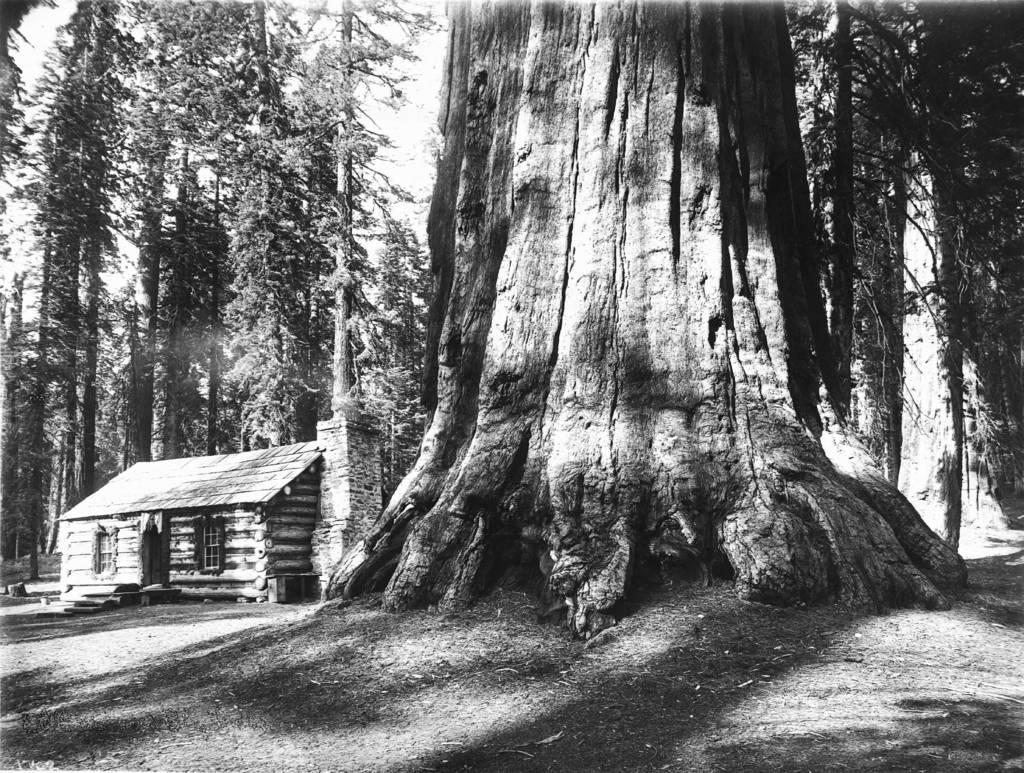What type of picture is in the image? The image contains a black and white picture of a house. What features can be seen on the house? The house has windows and a door. What else is present in the image besides the house? There is a group of trees in the image. What can be seen in the background of the image? The sky is visible in the image. What type of crown is worn by the tree in the image? There is no crown present in the image, as it features a black and white picture of a house with a group of trees and a visible sky. 